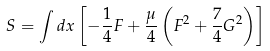<formula> <loc_0><loc_0><loc_500><loc_500>S = \int d x \left [ - \frac { 1 } { 4 } F + \frac { \mu } { 4 } \left ( F ^ { 2 } + \frac { 7 } { 4 } G ^ { 2 } \right ) \right ]</formula> 